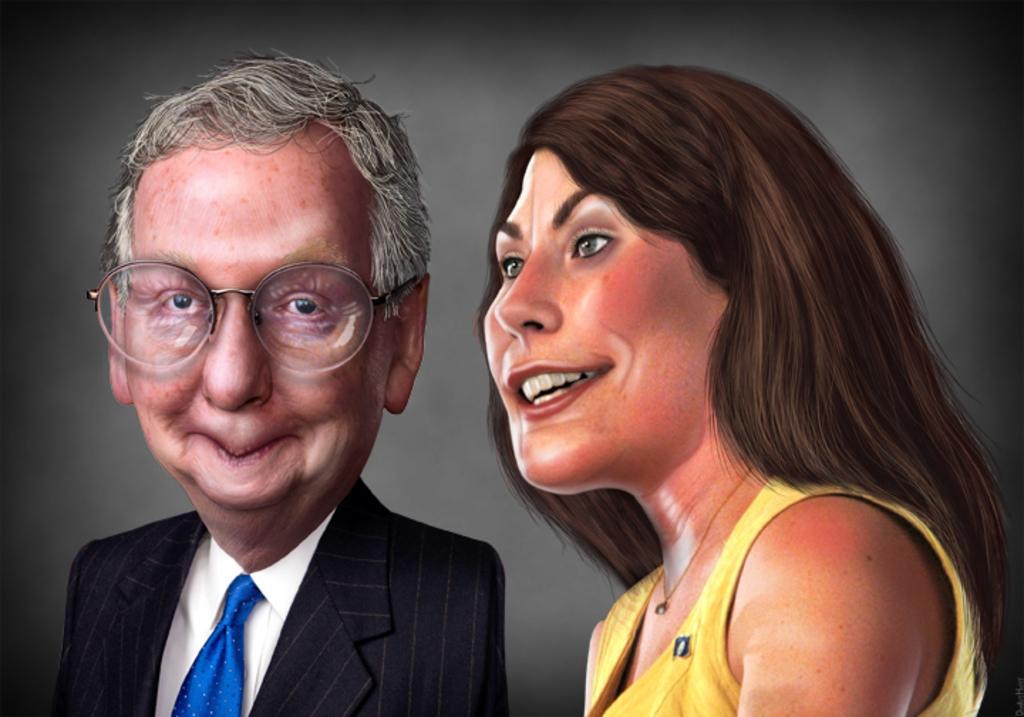Could you give a brief overview of what you see in this image? In this image we can see the picture of a man and a woman and it looks like a caricature. 